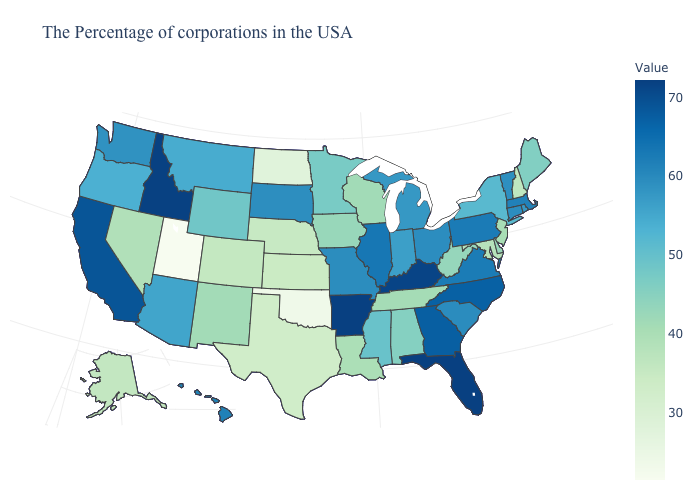Among the states that border Idaho , which have the lowest value?
Concise answer only. Utah. Does Indiana have a higher value than New Mexico?
Give a very brief answer. Yes. Among the states that border Ohio , does Indiana have the lowest value?
Be succinct. No. Among the states that border Utah , which have the highest value?
Keep it brief. Idaho. Which states have the highest value in the USA?
Short answer required. Florida, Arkansas. Among the states that border Georgia , does Tennessee have the lowest value?
Short answer required. Yes. Among the states that border New Jersey , which have the highest value?
Keep it brief. Pennsylvania. 